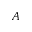Convert formula to latex. <formula><loc_0><loc_0><loc_500><loc_500>A</formula> 